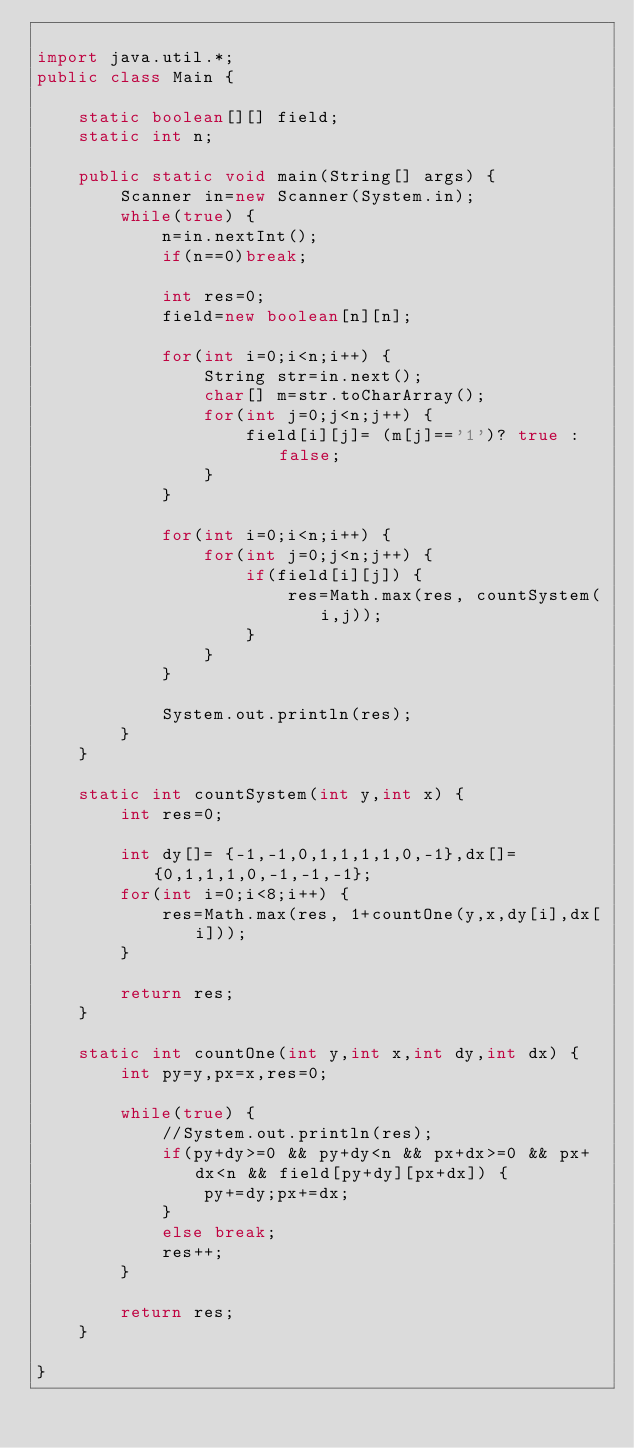Convert code to text. <code><loc_0><loc_0><loc_500><loc_500><_Java_>
import java.util.*;
public class Main {
	
	static boolean[][] field;
	static int n;
	
	public static void main(String[] args) {
		Scanner in=new Scanner(System.in);
		while(true) {
			n=in.nextInt();
			if(n==0)break;
			
			int res=0;
			field=new boolean[n][n];
			
			for(int i=0;i<n;i++) {
				String str=in.next();
				char[] m=str.toCharArray();
				for(int j=0;j<n;j++) {
					field[i][j]= (m[j]=='1')? true :false;
				}
			}
			
			for(int i=0;i<n;i++) {
				for(int j=0;j<n;j++) {
					if(field[i][j]) {
						res=Math.max(res, countSystem(i,j));
					}
				}
			}
			
			System.out.println(res);
		}
	}
	
	static int countSystem(int y,int x) {
		int res=0;
		
		int dy[]= {-1,-1,0,1,1,1,1,0,-1},dx[]= {0,1,1,1,0,-1,-1,-1};
		for(int i=0;i<8;i++) {
			res=Math.max(res, 1+countOne(y,x,dy[i],dx[i]));
		}
		
		return res;
	}
	
	static int countOne(int y,int x,int dy,int dx) {
		int py=y,px=x,res=0;
		
		while(true) {
			//System.out.println(res);
			if(py+dy>=0 && py+dy<n && px+dx>=0 && px+dx<n && field[py+dy][px+dx]) {
				py+=dy;px+=dx;
			}
			else break;
			res++;
		}
		
		return res;
	}

}

</code> 